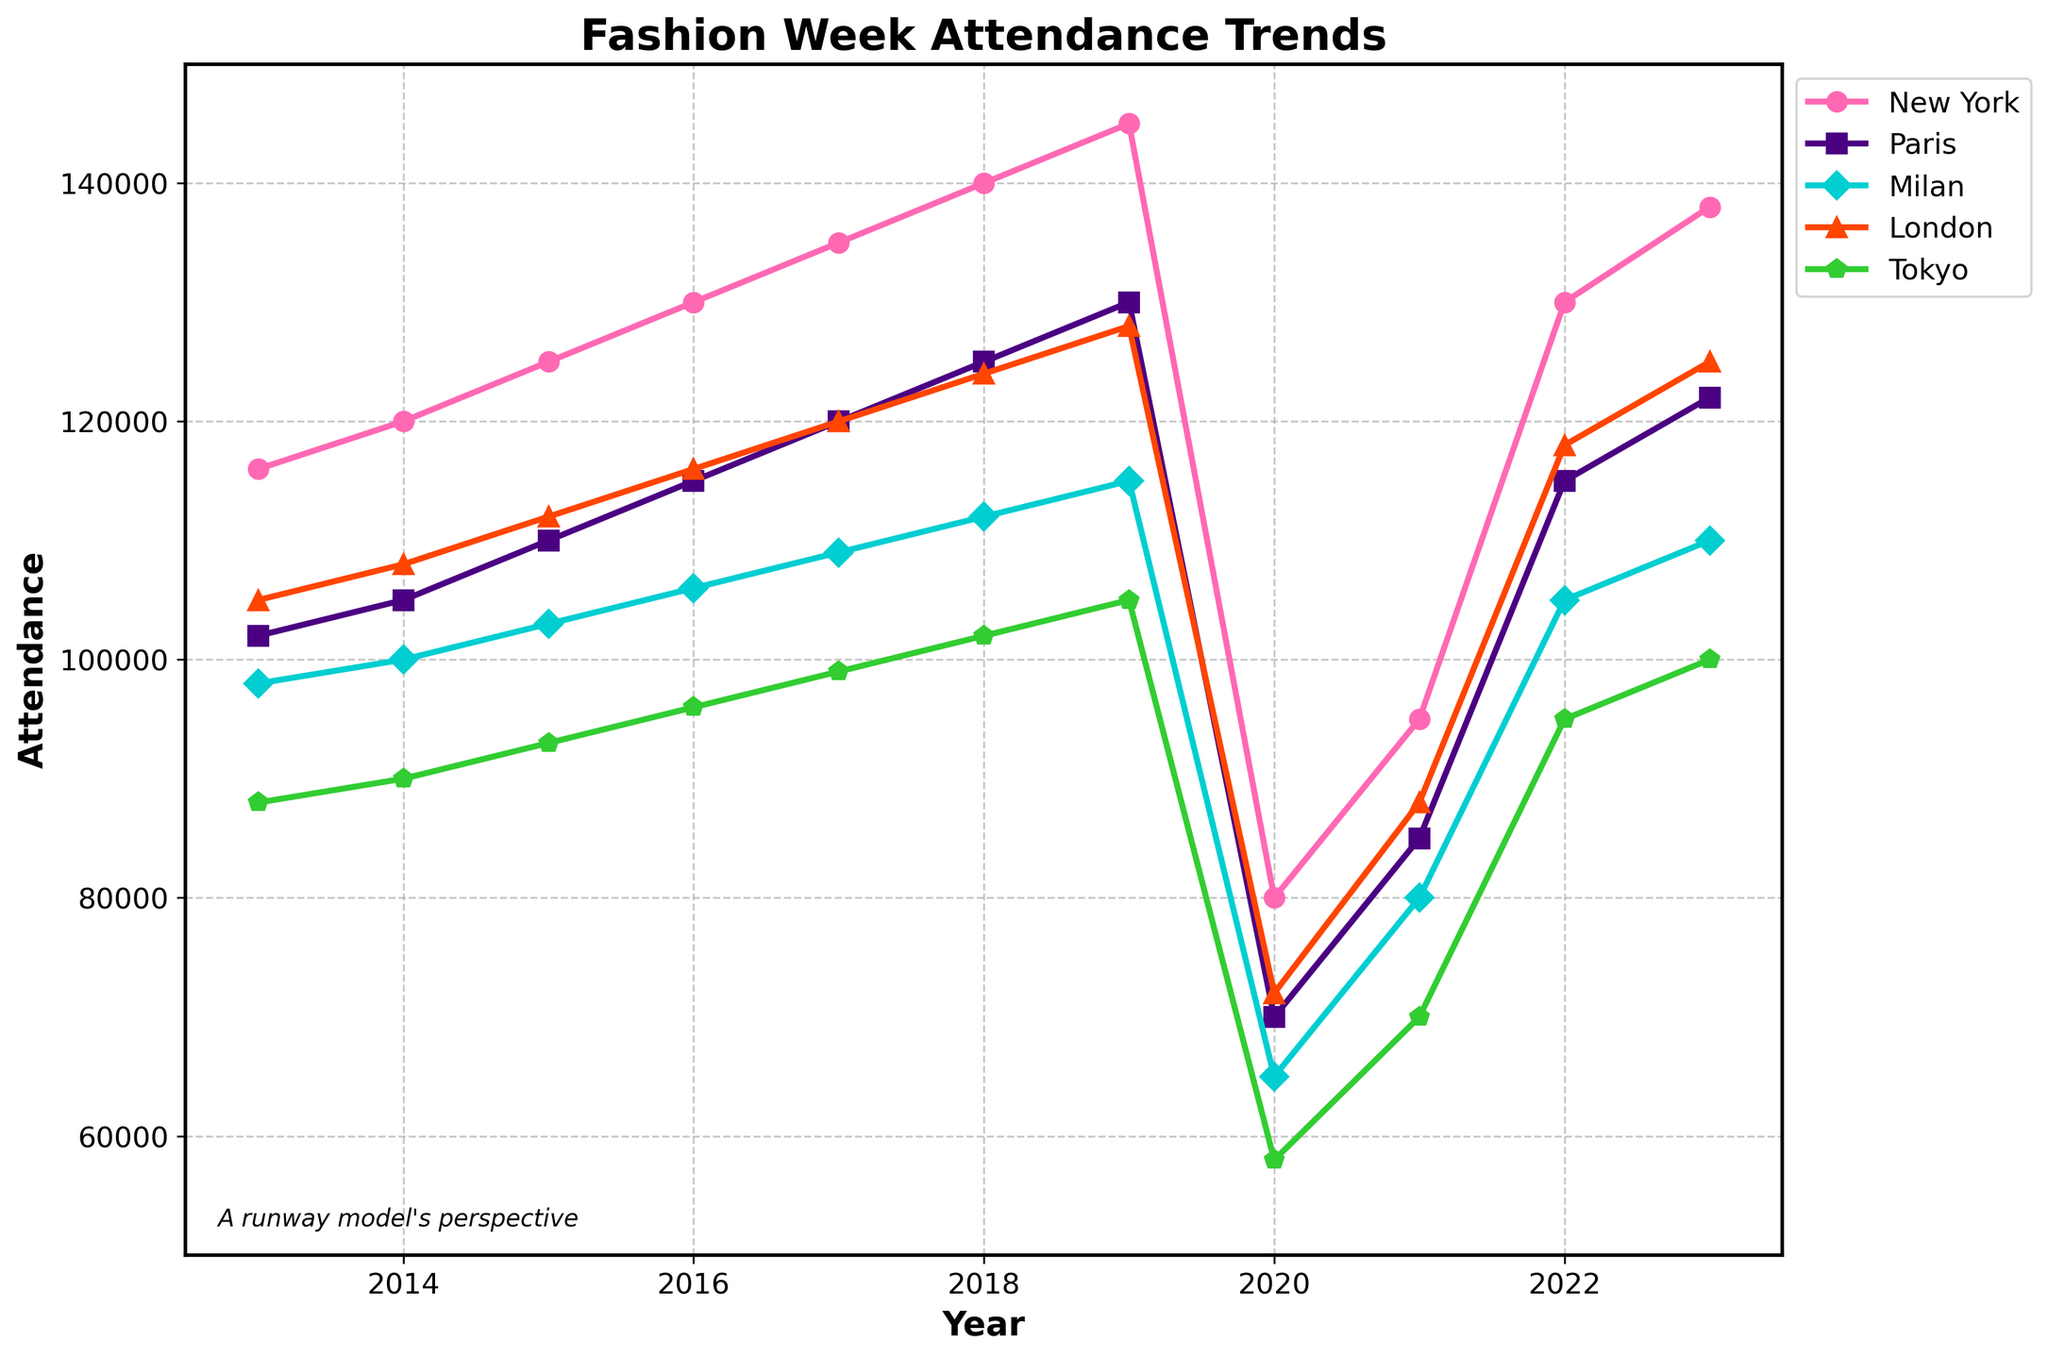What's the highest fashion week attendance for New York over the past decade? Look for the highest peak in the plot for New York. The highest data point for New York is at 145,000 in 2019.
Answer: 145,000 Which city had the lowest attendance in 2020? Observe the attendance values for all cities in 2020. Tokyo had the lowest attendance with 58,000.
Answer: Tokyo How did the attendance in Milan compare to Paris in 2021? Compare the plotted points for Milan and Paris in 2021. Milan had 80,000 attendees while Paris had 85,000, so Paris had more.
Answer: Paris had more What was the rate of increase in attendance for London from 2013 to 2019? Calculate the difference in attendance between 2013 and 2019 for London, then divide by the number of years (2019 - 2013 = 6 years). The attendance increased from 105,000 to 128,000, so the rate is (128,000 - 105,000) / 6.
Answer: 3,833.33 per year Which year showed the most significant decline in attendance across all cities? Identify the year with the steepest drop across all plotted lines. The year 2020 shows the most significant decline.
Answer: 2020 What is the average attendance for Paris over the decade? Sum the attendance values for Paris for all years and divide by the number of years (11). The total sum is 1,244,000. Therefore, the average is 1,244,000 / 11.
Answer: 113,090.91 Compare the recovery in attendance for New York and Tokyo between 2020 and 2023. Calculate the difference in attendance between 2020 and 2023 for both New York and Tokyo. For New York, it increased from 80,000 to 138,000, so the increase is 58,000. For Tokyo, it increased from 58,000 to 100,000, so the increase is 42,000.
Answer: New York recovered more Which city's attendance surpassed 100,000 for the first time in 2016? Look for the first point where the attendance goes above 100,000. Milan surpassed 100,000 in 2016.
Answer: Milan Find the visual trend for fashion week attendance in Milan over the decade. Observe the plotted line for Milan over the years. Initially, it increases steadily until 2019, drops sharply in 2020, and then shows a partial recovery.
Answer: Increase, sharp drop, partial recovery 